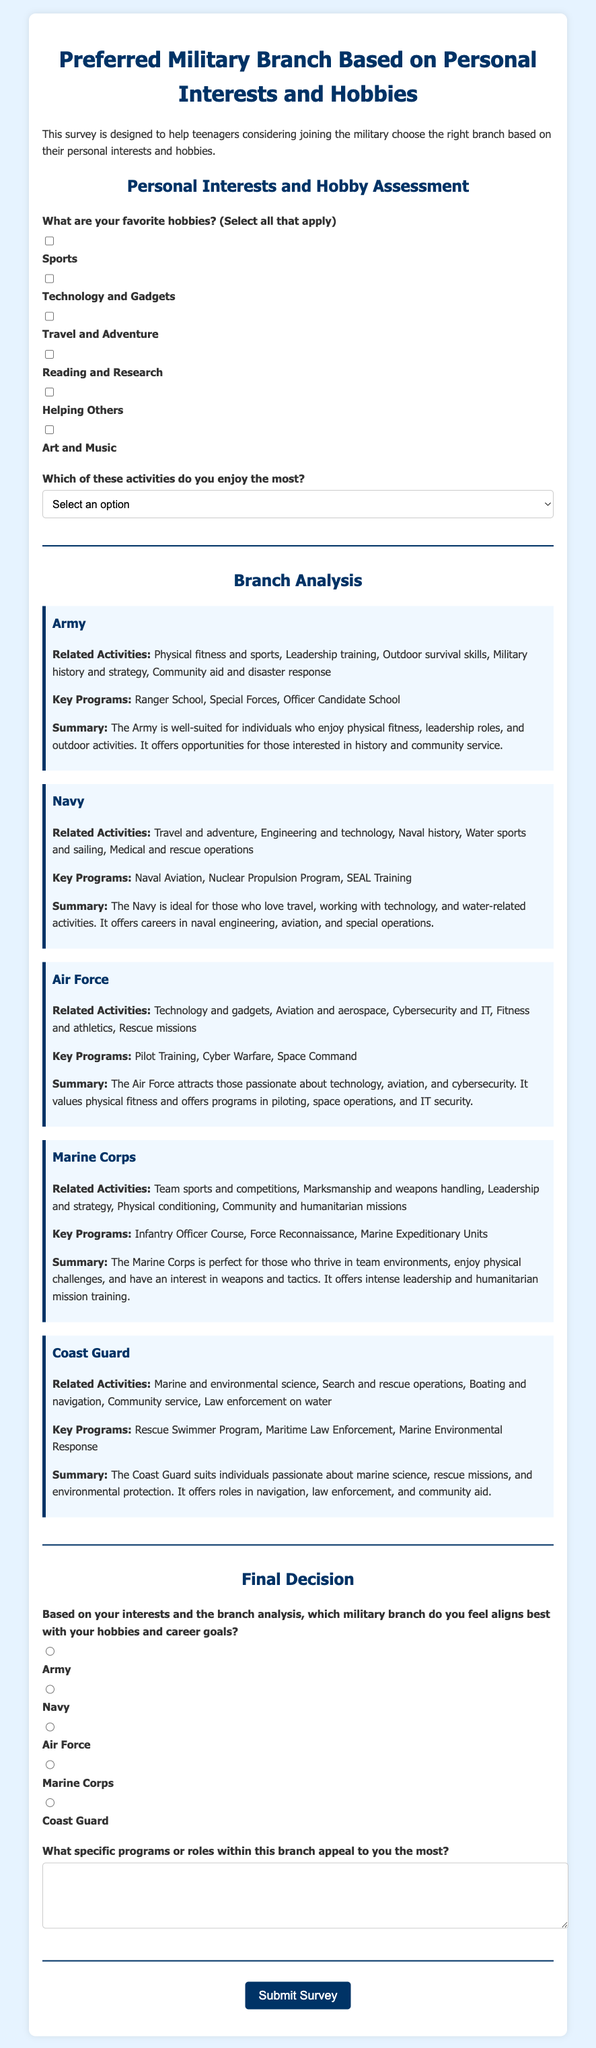What are the hobbies listed in the survey? The hobbies are listed as options in the survey and include Sports, Technology and Gadgets, Travel and Adventure, Reading and Research, Helping Others, and Art and Music.
Answer: Sports, Technology and Gadgets, Travel and Adventure, Reading and Research, Helping Others, Art and Music Which military branch is associated with naval history? The Navy branch analysis mentions naval history as one of its related activities.
Answer: Navy What program is highlighted under the Air Force? The Air Force branch analysis features several key programs, one being Pilot Training.
Answer: Pilot Training Which branch is ideal for someone who enjoys physical challenges and teamwork? The Marine Corps' analysis indicates it is perfect for individuals who thrive in team environments and enjoy physical challenges.
Answer: Marine Corps How many key programs are mentioned for the Coast Guard? The Coast Guard branch analysis lists three specific key programs: Rescue Swimmer Program, Maritime Law Enforcement, and Marine Environmental Response.
Answer: Three 